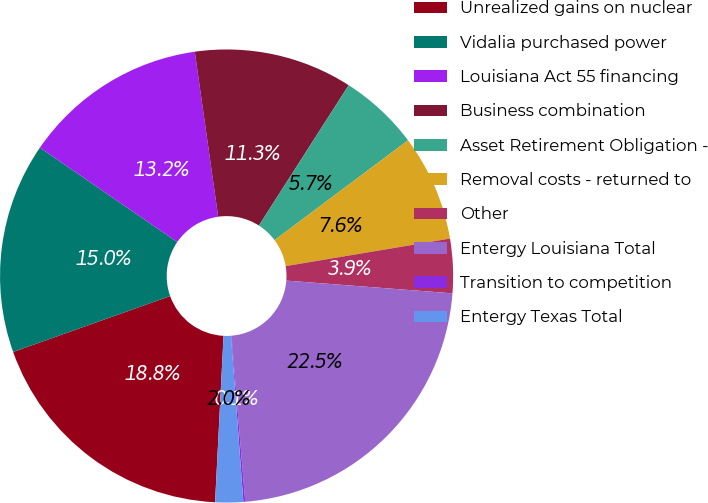Convert chart. <chart><loc_0><loc_0><loc_500><loc_500><pie_chart><fcel>Unrealized gains on nuclear<fcel>Vidalia purchased power<fcel>Louisiana Act 55 financing<fcel>Business combination<fcel>Asset Retirement Obligation -<fcel>Removal costs - returned to<fcel>Other<fcel>Entergy Louisiana Total<fcel>Transition to competition<fcel>Entergy Texas Total<nl><fcel>18.75%<fcel>15.03%<fcel>13.17%<fcel>11.3%<fcel>5.72%<fcel>7.58%<fcel>3.86%<fcel>22.47%<fcel>0.13%<fcel>1.99%<nl></chart> 